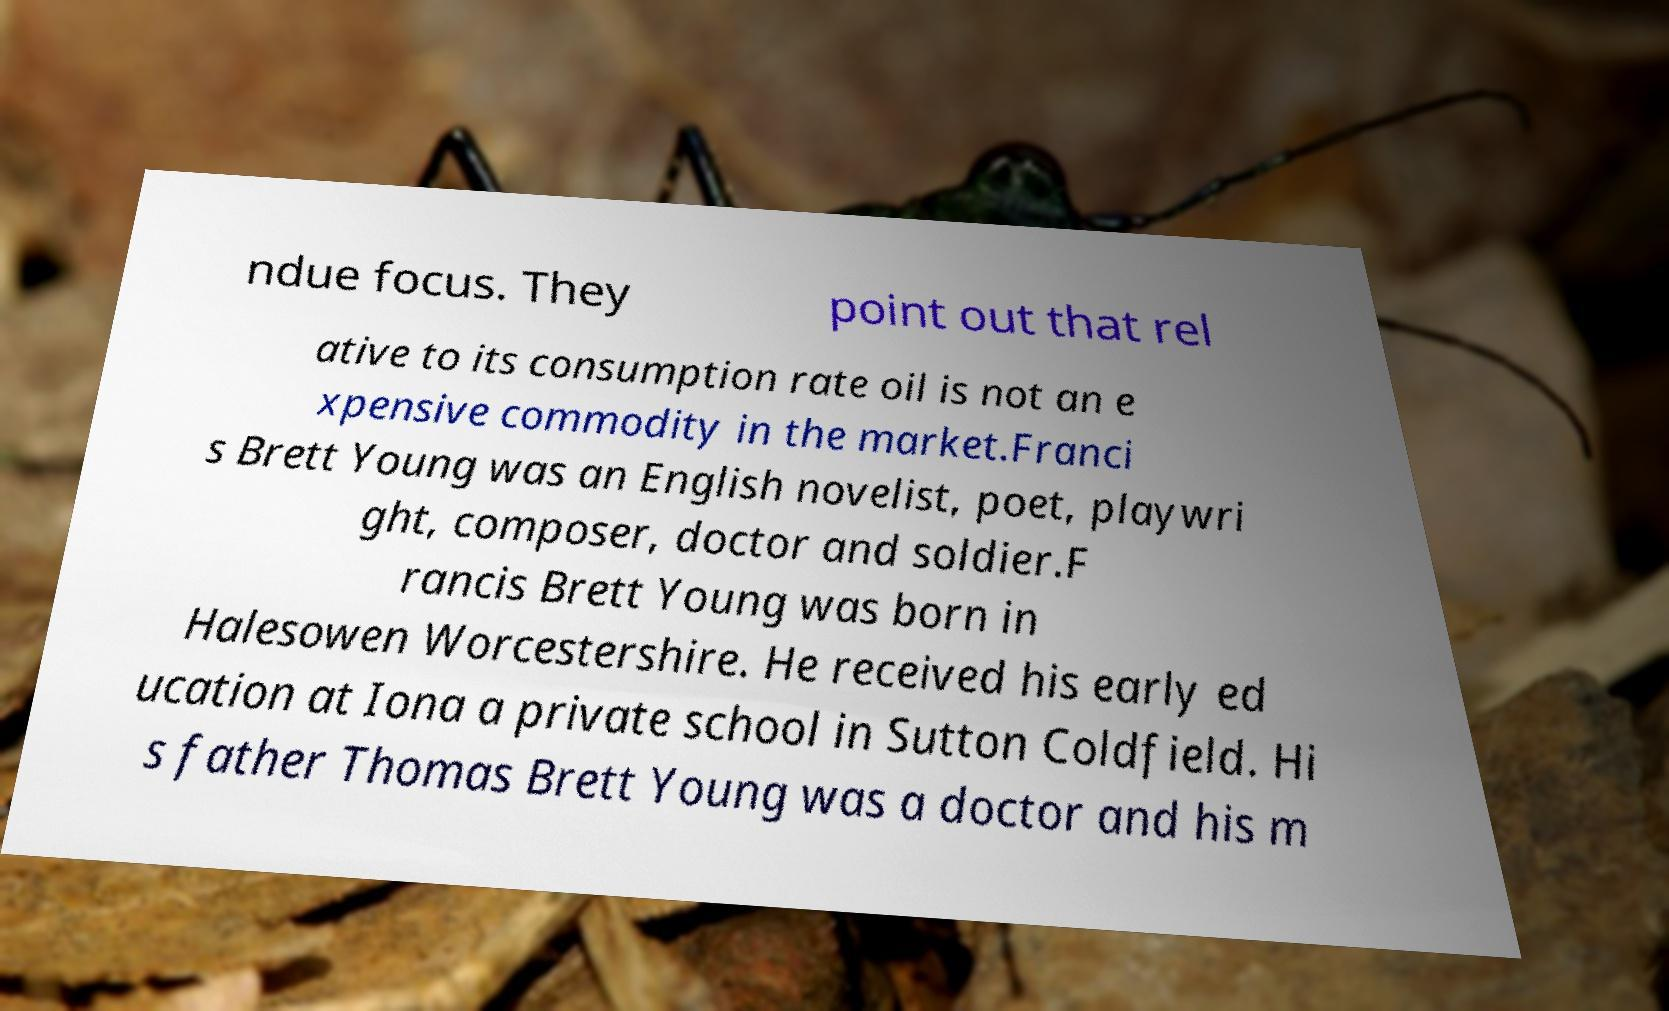Could you extract and type out the text from this image? ndue focus. They point out that rel ative to its consumption rate oil is not an e xpensive commodity in the market.Franci s Brett Young was an English novelist, poet, playwri ght, composer, doctor and soldier.F rancis Brett Young was born in Halesowen Worcestershire. He received his early ed ucation at Iona a private school in Sutton Coldfield. Hi s father Thomas Brett Young was a doctor and his m 